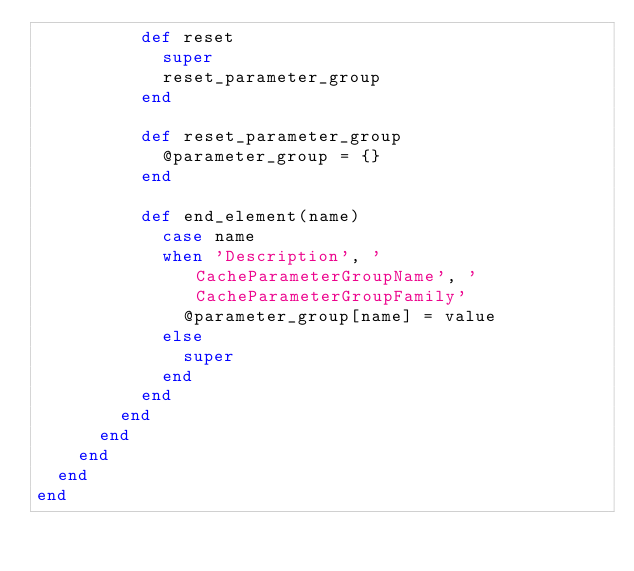Convert code to text. <code><loc_0><loc_0><loc_500><loc_500><_Ruby_>          def reset
            super
            reset_parameter_group
          end

          def reset_parameter_group
            @parameter_group = {}
          end

          def end_element(name)
            case name
            when 'Description', 'CacheParameterGroupName', 'CacheParameterGroupFamily'
              @parameter_group[name] = value
            else
              super
            end
          end
        end
      end
    end
  end
end
</code> 